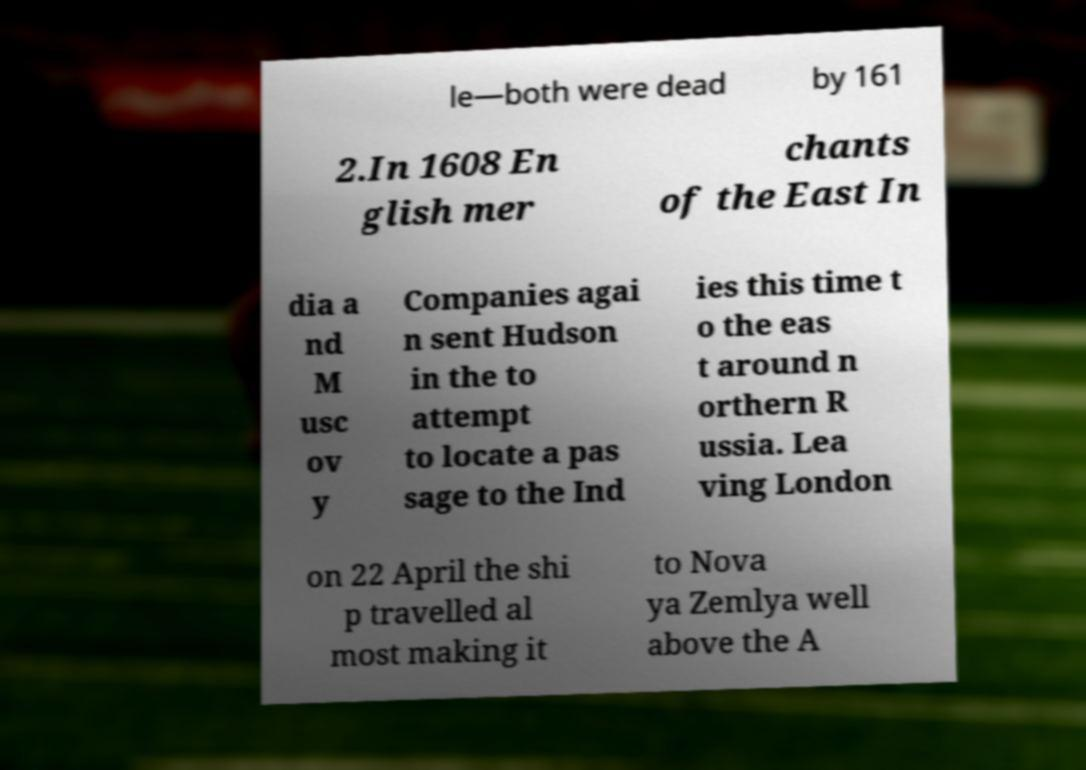Please identify and transcribe the text found in this image. le—both were dead by 161 2.In 1608 En glish mer chants of the East In dia a nd M usc ov y Companies agai n sent Hudson in the to attempt to locate a pas sage to the Ind ies this time t o the eas t around n orthern R ussia. Lea ving London on 22 April the shi p travelled al most making it to Nova ya Zemlya well above the A 